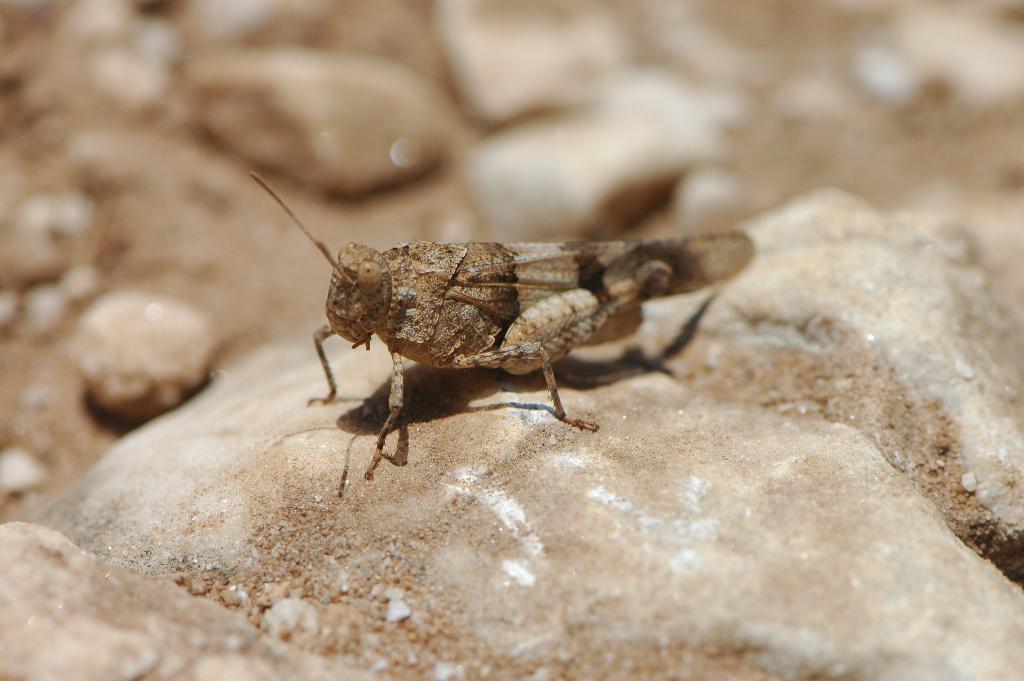In one or two sentences, can you explain what this image depicts? In this image, in the middle, we can see an insect standing on the grass. In the background, we can see some rocks. 